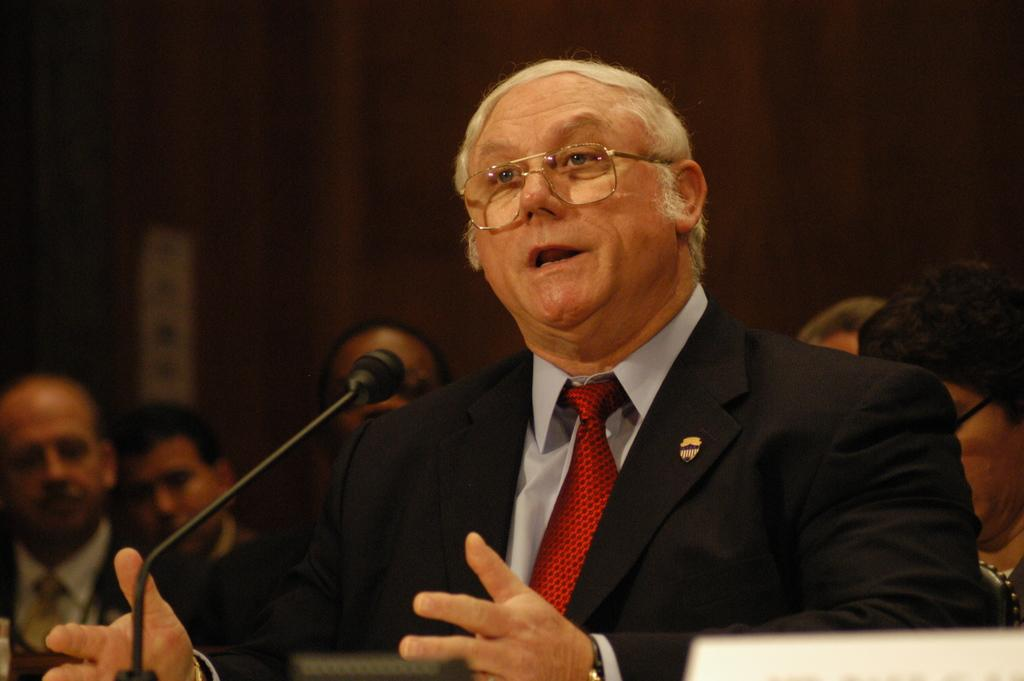Who is the main subject in the image? There is a man in the image. What is the man wearing? The man is wearing a suit. What is the man doing in the image? The man is talking in front of a microphone. Can you describe the people in the background of the image? There are people in the background of the image, but their appearance is not clear. What thrilling appliance can be seen in the man's hand in the image? There is no thrilling appliance visible in the man's hand in the image. 